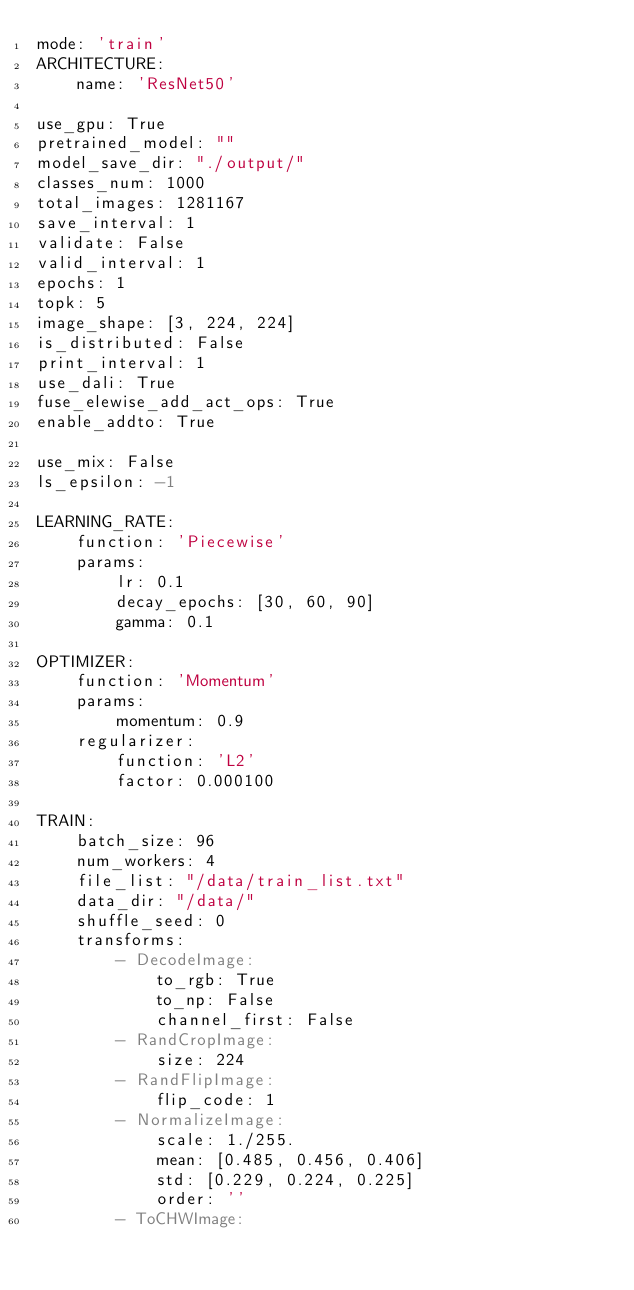Convert code to text. <code><loc_0><loc_0><loc_500><loc_500><_YAML_>mode: 'train'
ARCHITECTURE:
    name: 'ResNet50'

use_gpu: True
pretrained_model: ""
model_save_dir: "./output/"
classes_num: 1000
total_images: 1281167
save_interval: 1
validate: False
valid_interval: 1
epochs: 1
topk: 5
image_shape: [3, 224, 224]
is_distributed: False
print_interval: 1
use_dali: True
fuse_elewise_add_act_ops: True
enable_addto: True

use_mix: False
ls_epsilon: -1

LEARNING_RATE:
    function: 'Piecewise'          
    params:                   
        lr: 0.1               
        decay_epochs: [30, 60, 90] 
        gamma: 0.1 

OPTIMIZER:
    function: 'Momentum'
    params:
        momentum: 0.9
    regularizer:
        function: 'L2'
        factor: 0.000100

TRAIN:
    batch_size: 96
    num_workers: 4
    file_list: "/data/train_list.txt"
    data_dir: "/data/"
    shuffle_seed: 0
    transforms:
        - DecodeImage:
            to_rgb: True
            to_np: False
            channel_first: False
        - RandCropImage:
            size: 224
        - RandFlipImage:
            flip_code: 1
        - NormalizeImage:
            scale: 1./255.
            mean: [0.485, 0.456, 0.406]
            std: [0.229, 0.224, 0.225]
            order: ''
        - ToCHWImage:
</code> 